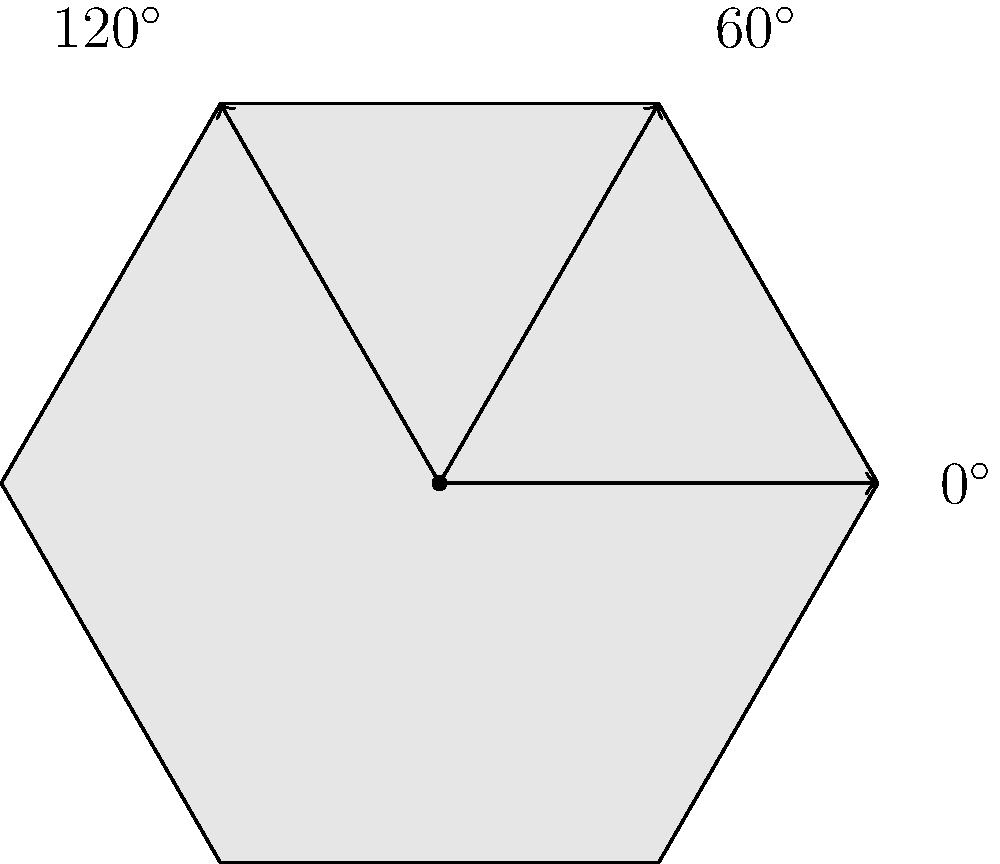As a fellow commercial artist, you're designing a custom guitar pick for a rock band. The pick has a hexagonal shape with perfect 60° rotational symmetry, as shown in the diagram. What is the order of the rotation group for this guitar pick shape, and how does this relate to the concept of musical harmony in a standard guitar tuning? Let's approach this step-by-step:

1) First, we need to understand what the order of a rotation group means. It's the number of distinct rotations that bring the shape back to its original position.

2) Looking at the hexagonal guitar pick, we can see that it has 6 vertices and 6 edges.

3) The pick can be rotated by multiples of 60° to return to its original position:
   - 0° (identity rotation)
   - 60°
   - 120°
   - 180°
   - 240°
   - 300°

4) After a 360° rotation, we're back where we started, and the pattern repeats.

5) Therefore, the order of the rotation group is 6.

6) Now, let's relate this to musical harmony in standard guitar tuning:

   - A standard guitar has 6 strings, which matches the order of our rotation group.
   - The standard tuning (E-A-D-G-B-E) is based on intervals of perfect fourths (with one exception between G and B).
   - The number 6 is significant in music theory:
     * There are 6 whole tones in an octave.
     * Many common chord progressions use 6 chords (e.g., I-V-vi-IV-I-V).

7) Just as the hexagonal pick has a harmonious symmetry that repeats every 60°, the 6-string guitar allows for harmonic structures that repeat and resolve in musical compositions.

This connection between the mathematical symmetry of the pick's shape and the harmonic structure of the guitar illustrates the deep relationship between mathematics and music, a concept often explored in commercial art and music production.
Answer: Order 6; mirrors 6-string harmony 